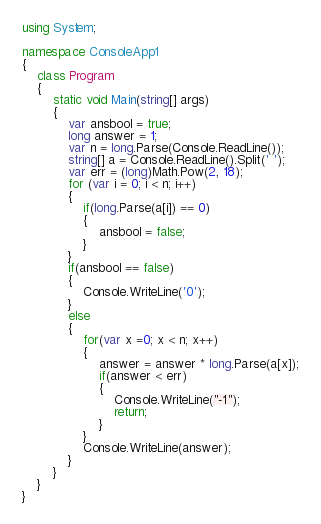Convert code to text. <code><loc_0><loc_0><loc_500><loc_500><_C#_>using System;

namespace ConsoleApp1
{
    class Program
    {
        static void Main(string[] args)
        {
            var ansbool = true;
            long answer = 1;
            var n = long.Parse(Console.ReadLine());
            string[] a = Console.ReadLine().Split(' ');
            var err = (long)Math.Pow(2, 18);
            for (var i = 0; i < n; i++)
            {
                if(long.Parse(a[i]) == 0)
                {
                    ansbool = false;
                }
            }
            if(ansbool == false)
            {
                Console.WriteLine('0');
            }
            else
            {
                for(var x =0; x < n; x++)
                {
                    answer = answer * long.Parse(a[x]);
                    if(answer < err)
                    {
                        Console.WriteLine("-1");
                        return;
                    }
                }
                Console.WriteLine(answer);
            }
        }
    }
}
</code> 